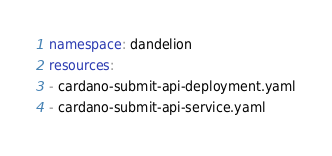<code> <loc_0><loc_0><loc_500><loc_500><_YAML_>namespace: dandelion
resources:
- cardano-submit-api-deployment.yaml
- cardano-submit-api-service.yaml
</code> 